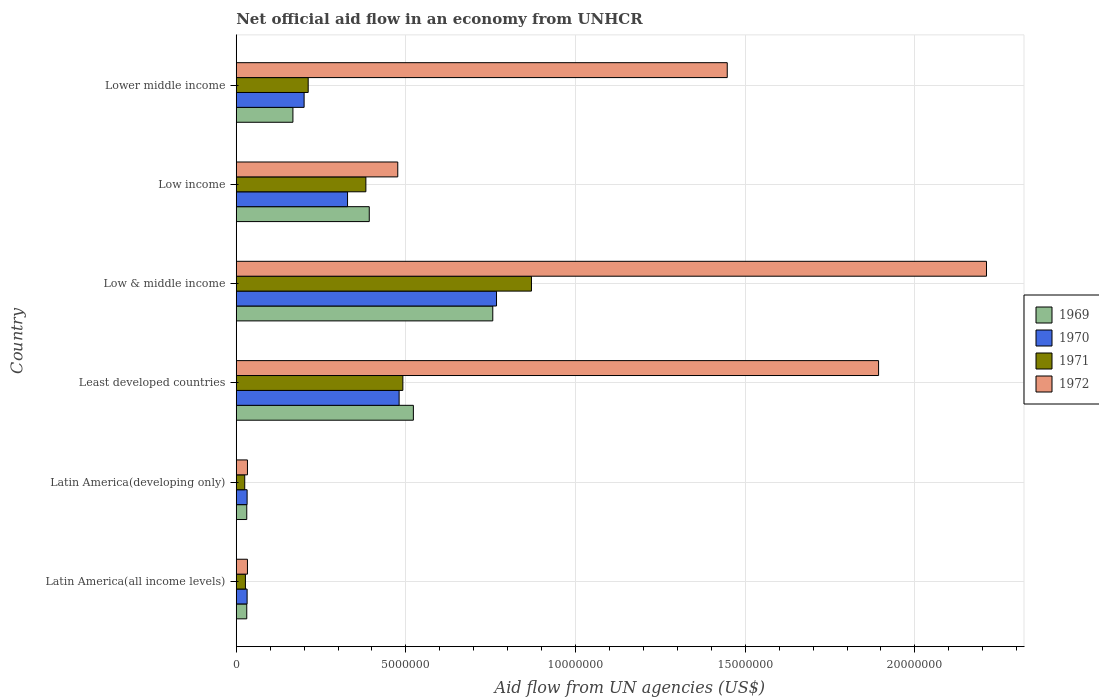How many groups of bars are there?
Offer a terse response. 6. Are the number of bars on each tick of the Y-axis equal?
Keep it short and to the point. Yes. How many bars are there on the 2nd tick from the bottom?
Give a very brief answer. 4. What is the label of the 3rd group of bars from the top?
Your response must be concise. Low & middle income. What is the net official aid flow in 1970 in Latin America(developing only)?
Your answer should be compact. 3.20e+05. Across all countries, what is the maximum net official aid flow in 1969?
Provide a short and direct response. 7.56e+06. Across all countries, what is the minimum net official aid flow in 1969?
Provide a succinct answer. 3.10e+05. In which country was the net official aid flow in 1969 minimum?
Keep it short and to the point. Latin America(all income levels). What is the total net official aid flow in 1970 in the graph?
Keep it short and to the point. 1.84e+07. What is the difference between the net official aid flow in 1972 in Latin America(developing only) and that in Lower middle income?
Keep it short and to the point. -1.41e+07. What is the difference between the net official aid flow in 1971 in Least developed countries and the net official aid flow in 1969 in Low & middle income?
Ensure brevity in your answer.  -2.65e+06. What is the average net official aid flow in 1969 per country?
Ensure brevity in your answer.  3.16e+06. What is the difference between the net official aid flow in 1971 and net official aid flow in 1969 in Low & middle income?
Your answer should be compact. 1.14e+06. What is the ratio of the net official aid flow in 1970 in Latin America(all income levels) to that in Lower middle income?
Your response must be concise. 0.16. What is the difference between the highest and the second highest net official aid flow in 1972?
Provide a succinct answer. 3.18e+06. What is the difference between the highest and the lowest net official aid flow in 1969?
Provide a succinct answer. 7.25e+06. Is it the case that in every country, the sum of the net official aid flow in 1971 and net official aid flow in 1972 is greater than the sum of net official aid flow in 1970 and net official aid flow in 1969?
Ensure brevity in your answer.  No. What does the 2nd bar from the top in Least developed countries represents?
Ensure brevity in your answer.  1971. What does the 3rd bar from the bottom in Low & middle income represents?
Your answer should be very brief. 1971. How many bars are there?
Make the answer very short. 24. How many countries are there in the graph?
Offer a very short reply. 6. What is the difference between two consecutive major ticks on the X-axis?
Offer a very short reply. 5.00e+06. How many legend labels are there?
Offer a very short reply. 4. What is the title of the graph?
Offer a very short reply. Net official aid flow in an economy from UNHCR. What is the label or title of the X-axis?
Give a very brief answer. Aid flow from UN agencies (US$). What is the Aid flow from UN agencies (US$) of 1969 in Latin America(all income levels)?
Offer a terse response. 3.10e+05. What is the Aid flow from UN agencies (US$) in 1972 in Latin America(all income levels)?
Your response must be concise. 3.30e+05. What is the Aid flow from UN agencies (US$) in 1969 in Least developed countries?
Your answer should be very brief. 5.22e+06. What is the Aid flow from UN agencies (US$) of 1970 in Least developed countries?
Make the answer very short. 4.80e+06. What is the Aid flow from UN agencies (US$) of 1971 in Least developed countries?
Ensure brevity in your answer.  4.91e+06. What is the Aid flow from UN agencies (US$) in 1972 in Least developed countries?
Keep it short and to the point. 1.89e+07. What is the Aid flow from UN agencies (US$) of 1969 in Low & middle income?
Provide a short and direct response. 7.56e+06. What is the Aid flow from UN agencies (US$) of 1970 in Low & middle income?
Offer a terse response. 7.67e+06. What is the Aid flow from UN agencies (US$) in 1971 in Low & middle income?
Give a very brief answer. 8.70e+06. What is the Aid flow from UN agencies (US$) of 1972 in Low & middle income?
Make the answer very short. 2.21e+07. What is the Aid flow from UN agencies (US$) in 1969 in Low income?
Your answer should be compact. 3.92e+06. What is the Aid flow from UN agencies (US$) in 1970 in Low income?
Your answer should be very brief. 3.28e+06. What is the Aid flow from UN agencies (US$) of 1971 in Low income?
Offer a terse response. 3.82e+06. What is the Aid flow from UN agencies (US$) in 1972 in Low income?
Give a very brief answer. 4.76e+06. What is the Aid flow from UN agencies (US$) in 1969 in Lower middle income?
Your answer should be compact. 1.67e+06. What is the Aid flow from UN agencies (US$) in 1971 in Lower middle income?
Ensure brevity in your answer.  2.12e+06. What is the Aid flow from UN agencies (US$) of 1972 in Lower middle income?
Ensure brevity in your answer.  1.45e+07. Across all countries, what is the maximum Aid flow from UN agencies (US$) in 1969?
Your answer should be very brief. 7.56e+06. Across all countries, what is the maximum Aid flow from UN agencies (US$) in 1970?
Provide a succinct answer. 7.67e+06. Across all countries, what is the maximum Aid flow from UN agencies (US$) in 1971?
Offer a very short reply. 8.70e+06. Across all countries, what is the maximum Aid flow from UN agencies (US$) of 1972?
Ensure brevity in your answer.  2.21e+07. Across all countries, what is the minimum Aid flow from UN agencies (US$) of 1972?
Ensure brevity in your answer.  3.30e+05. What is the total Aid flow from UN agencies (US$) of 1969 in the graph?
Offer a terse response. 1.90e+07. What is the total Aid flow from UN agencies (US$) in 1970 in the graph?
Make the answer very short. 1.84e+07. What is the total Aid flow from UN agencies (US$) in 1971 in the graph?
Keep it short and to the point. 2.01e+07. What is the total Aid flow from UN agencies (US$) in 1972 in the graph?
Your response must be concise. 6.09e+07. What is the difference between the Aid flow from UN agencies (US$) of 1969 in Latin America(all income levels) and that in Latin America(developing only)?
Provide a short and direct response. 0. What is the difference between the Aid flow from UN agencies (US$) of 1970 in Latin America(all income levels) and that in Latin America(developing only)?
Offer a terse response. 0. What is the difference between the Aid flow from UN agencies (US$) in 1969 in Latin America(all income levels) and that in Least developed countries?
Provide a short and direct response. -4.91e+06. What is the difference between the Aid flow from UN agencies (US$) in 1970 in Latin America(all income levels) and that in Least developed countries?
Offer a terse response. -4.48e+06. What is the difference between the Aid flow from UN agencies (US$) in 1971 in Latin America(all income levels) and that in Least developed countries?
Provide a short and direct response. -4.64e+06. What is the difference between the Aid flow from UN agencies (US$) of 1972 in Latin America(all income levels) and that in Least developed countries?
Make the answer very short. -1.86e+07. What is the difference between the Aid flow from UN agencies (US$) of 1969 in Latin America(all income levels) and that in Low & middle income?
Offer a terse response. -7.25e+06. What is the difference between the Aid flow from UN agencies (US$) of 1970 in Latin America(all income levels) and that in Low & middle income?
Give a very brief answer. -7.35e+06. What is the difference between the Aid flow from UN agencies (US$) of 1971 in Latin America(all income levels) and that in Low & middle income?
Provide a succinct answer. -8.43e+06. What is the difference between the Aid flow from UN agencies (US$) in 1972 in Latin America(all income levels) and that in Low & middle income?
Your response must be concise. -2.18e+07. What is the difference between the Aid flow from UN agencies (US$) of 1969 in Latin America(all income levels) and that in Low income?
Give a very brief answer. -3.61e+06. What is the difference between the Aid flow from UN agencies (US$) in 1970 in Latin America(all income levels) and that in Low income?
Your answer should be compact. -2.96e+06. What is the difference between the Aid flow from UN agencies (US$) in 1971 in Latin America(all income levels) and that in Low income?
Ensure brevity in your answer.  -3.55e+06. What is the difference between the Aid flow from UN agencies (US$) in 1972 in Latin America(all income levels) and that in Low income?
Keep it short and to the point. -4.43e+06. What is the difference between the Aid flow from UN agencies (US$) of 1969 in Latin America(all income levels) and that in Lower middle income?
Your answer should be very brief. -1.36e+06. What is the difference between the Aid flow from UN agencies (US$) of 1970 in Latin America(all income levels) and that in Lower middle income?
Provide a short and direct response. -1.68e+06. What is the difference between the Aid flow from UN agencies (US$) in 1971 in Latin America(all income levels) and that in Lower middle income?
Give a very brief answer. -1.85e+06. What is the difference between the Aid flow from UN agencies (US$) of 1972 in Latin America(all income levels) and that in Lower middle income?
Offer a very short reply. -1.41e+07. What is the difference between the Aid flow from UN agencies (US$) in 1969 in Latin America(developing only) and that in Least developed countries?
Keep it short and to the point. -4.91e+06. What is the difference between the Aid flow from UN agencies (US$) of 1970 in Latin America(developing only) and that in Least developed countries?
Provide a short and direct response. -4.48e+06. What is the difference between the Aid flow from UN agencies (US$) in 1971 in Latin America(developing only) and that in Least developed countries?
Offer a very short reply. -4.66e+06. What is the difference between the Aid flow from UN agencies (US$) in 1972 in Latin America(developing only) and that in Least developed countries?
Give a very brief answer. -1.86e+07. What is the difference between the Aid flow from UN agencies (US$) of 1969 in Latin America(developing only) and that in Low & middle income?
Keep it short and to the point. -7.25e+06. What is the difference between the Aid flow from UN agencies (US$) in 1970 in Latin America(developing only) and that in Low & middle income?
Your response must be concise. -7.35e+06. What is the difference between the Aid flow from UN agencies (US$) of 1971 in Latin America(developing only) and that in Low & middle income?
Keep it short and to the point. -8.45e+06. What is the difference between the Aid flow from UN agencies (US$) of 1972 in Latin America(developing only) and that in Low & middle income?
Provide a succinct answer. -2.18e+07. What is the difference between the Aid flow from UN agencies (US$) in 1969 in Latin America(developing only) and that in Low income?
Your answer should be compact. -3.61e+06. What is the difference between the Aid flow from UN agencies (US$) in 1970 in Latin America(developing only) and that in Low income?
Give a very brief answer. -2.96e+06. What is the difference between the Aid flow from UN agencies (US$) in 1971 in Latin America(developing only) and that in Low income?
Your response must be concise. -3.57e+06. What is the difference between the Aid flow from UN agencies (US$) in 1972 in Latin America(developing only) and that in Low income?
Ensure brevity in your answer.  -4.43e+06. What is the difference between the Aid flow from UN agencies (US$) in 1969 in Latin America(developing only) and that in Lower middle income?
Your answer should be compact. -1.36e+06. What is the difference between the Aid flow from UN agencies (US$) in 1970 in Latin America(developing only) and that in Lower middle income?
Offer a terse response. -1.68e+06. What is the difference between the Aid flow from UN agencies (US$) of 1971 in Latin America(developing only) and that in Lower middle income?
Provide a succinct answer. -1.87e+06. What is the difference between the Aid flow from UN agencies (US$) of 1972 in Latin America(developing only) and that in Lower middle income?
Your answer should be compact. -1.41e+07. What is the difference between the Aid flow from UN agencies (US$) in 1969 in Least developed countries and that in Low & middle income?
Your answer should be compact. -2.34e+06. What is the difference between the Aid flow from UN agencies (US$) of 1970 in Least developed countries and that in Low & middle income?
Your answer should be compact. -2.87e+06. What is the difference between the Aid flow from UN agencies (US$) of 1971 in Least developed countries and that in Low & middle income?
Ensure brevity in your answer.  -3.79e+06. What is the difference between the Aid flow from UN agencies (US$) of 1972 in Least developed countries and that in Low & middle income?
Provide a succinct answer. -3.18e+06. What is the difference between the Aid flow from UN agencies (US$) of 1969 in Least developed countries and that in Low income?
Your answer should be compact. 1.30e+06. What is the difference between the Aid flow from UN agencies (US$) in 1970 in Least developed countries and that in Low income?
Ensure brevity in your answer.  1.52e+06. What is the difference between the Aid flow from UN agencies (US$) in 1971 in Least developed countries and that in Low income?
Make the answer very short. 1.09e+06. What is the difference between the Aid flow from UN agencies (US$) of 1972 in Least developed countries and that in Low income?
Offer a very short reply. 1.42e+07. What is the difference between the Aid flow from UN agencies (US$) of 1969 in Least developed countries and that in Lower middle income?
Offer a terse response. 3.55e+06. What is the difference between the Aid flow from UN agencies (US$) in 1970 in Least developed countries and that in Lower middle income?
Offer a terse response. 2.80e+06. What is the difference between the Aid flow from UN agencies (US$) in 1971 in Least developed countries and that in Lower middle income?
Keep it short and to the point. 2.79e+06. What is the difference between the Aid flow from UN agencies (US$) in 1972 in Least developed countries and that in Lower middle income?
Make the answer very short. 4.46e+06. What is the difference between the Aid flow from UN agencies (US$) in 1969 in Low & middle income and that in Low income?
Provide a succinct answer. 3.64e+06. What is the difference between the Aid flow from UN agencies (US$) in 1970 in Low & middle income and that in Low income?
Your response must be concise. 4.39e+06. What is the difference between the Aid flow from UN agencies (US$) in 1971 in Low & middle income and that in Low income?
Ensure brevity in your answer.  4.88e+06. What is the difference between the Aid flow from UN agencies (US$) of 1972 in Low & middle income and that in Low income?
Your answer should be very brief. 1.74e+07. What is the difference between the Aid flow from UN agencies (US$) in 1969 in Low & middle income and that in Lower middle income?
Your response must be concise. 5.89e+06. What is the difference between the Aid flow from UN agencies (US$) in 1970 in Low & middle income and that in Lower middle income?
Give a very brief answer. 5.67e+06. What is the difference between the Aid flow from UN agencies (US$) of 1971 in Low & middle income and that in Lower middle income?
Give a very brief answer. 6.58e+06. What is the difference between the Aid flow from UN agencies (US$) in 1972 in Low & middle income and that in Lower middle income?
Your answer should be compact. 7.64e+06. What is the difference between the Aid flow from UN agencies (US$) in 1969 in Low income and that in Lower middle income?
Offer a terse response. 2.25e+06. What is the difference between the Aid flow from UN agencies (US$) in 1970 in Low income and that in Lower middle income?
Your response must be concise. 1.28e+06. What is the difference between the Aid flow from UN agencies (US$) in 1971 in Low income and that in Lower middle income?
Keep it short and to the point. 1.70e+06. What is the difference between the Aid flow from UN agencies (US$) in 1972 in Low income and that in Lower middle income?
Make the answer very short. -9.71e+06. What is the difference between the Aid flow from UN agencies (US$) of 1969 in Latin America(all income levels) and the Aid flow from UN agencies (US$) of 1971 in Latin America(developing only)?
Your answer should be very brief. 6.00e+04. What is the difference between the Aid flow from UN agencies (US$) of 1969 in Latin America(all income levels) and the Aid flow from UN agencies (US$) of 1970 in Least developed countries?
Your answer should be compact. -4.49e+06. What is the difference between the Aid flow from UN agencies (US$) of 1969 in Latin America(all income levels) and the Aid flow from UN agencies (US$) of 1971 in Least developed countries?
Offer a terse response. -4.60e+06. What is the difference between the Aid flow from UN agencies (US$) in 1969 in Latin America(all income levels) and the Aid flow from UN agencies (US$) in 1972 in Least developed countries?
Offer a terse response. -1.86e+07. What is the difference between the Aid flow from UN agencies (US$) of 1970 in Latin America(all income levels) and the Aid flow from UN agencies (US$) of 1971 in Least developed countries?
Give a very brief answer. -4.59e+06. What is the difference between the Aid flow from UN agencies (US$) in 1970 in Latin America(all income levels) and the Aid flow from UN agencies (US$) in 1972 in Least developed countries?
Your answer should be very brief. -1.86e+07. What is the difference between the Aid flow from UN agencies (US$) in 1971 in Latin America(all income levels) and the Aid flow from UN agencies (US$) in 1972 in Least developed countries?
Keep it short and to the point. -1.87e+07. What is the difference between the Aid flow from UN agencies (US$) of 1969 in Latin America(all income levels) and the Aid flow from UN agencies (US$) of 1970 in Low & middle income?
Ensure brevity in your answer.  -7.36e+06. What is the difference between the Aid flow from UN agencies (US$) in 1969 in Latin America(all income levels) and the Aid flow from UN agencies (US$) in 1971 in Low & middle income?
Your response must be concise. -8.39e+06. What is the difference between the Aid flow from UN agencies (US$) of 1969 in Latin America(all income levels) and the Aid flow from UN agencies (US$) of 1972 in Low & middle income?
Provide a short and direct response. -2.18e+07. What is the difference between the Aid flow from UN agencies (US$) of 1970 in Latin America(all income levels) and the Aid flow from UN agencies (US$) of 1971 in Low & middle income?
Ensure brevity in your answer.  -8.38e+06. What is the difference between the Aid flow from UN agencies (US$) in 1970 in Latin America(all income levels) and the Aid flow from UN agencies (US$) in 1972 in Low & middle income?
Offer a very short reply. -2.18e+07. What is the difference between the Aid flow from UN agencies (US$) in 1971 in Latin America(all income levels) and the Aid flow from UN agencies (US$) in 1972 in Low & middle income?
Provide a succinct answer. -2.18e+07. What is the difference between the Aid flow from UN agencies (US$) of 1969 in Latin America(all income levels) and the Aid flow from UN agencies (US$) of 1970 in Low income?
Keep it short and to the point. -2.97e+06. What is the difference between the Aid flow from UN agencies (US$) of 1969 in Latin America(all income levels) and the Aid flow from UN agencies (US$) of 1971 in Low income?
Offer a very short reply. -3.51e+06. What is the difference between the Aid flow from UN agencies (US$) of 1969 in Latin America(all income levels) and the Aid flow from UN agencies (US$) of 1972 in Low income?
Your response must be concise. -4.45e+06. What is the difference between the Aid flow from UN agencies (US$) in 1970 in Latin America(all income levels) and the Aid flow from UN agencies (US$) in 1971 in Low income?
Your response must be concise. -3.50e+06. What is the difference between the Aid flow from UN agencies (US$) in 1970 in Latin America(all income levels) and the Aid flow from UN agencies (US$) in 1972 in Low income?
Offer a terse response. -4.44e+06. What is the difference between the Aid flow from UN agencies (US$) of 1971 in Latin America(all income levels) and the Aid flow from UN agencies (US$) of 1972 in Low income?
Make the answer very short. -4.49e+06. What is the difference between the Aid flow from UN agencies (US$) in 1969 in Latin America(all income levels) and the Aid flow from UN agencies (US$) in 1970 in Lower middle income?
Provide a succinct answer. -1.69e+06. What is the difference between the Aid flow from UN agencies (US$) in 1969 in Latin America(all income levels) and the Aid flow from UN agencies (US$) in 1971 in Lower middle income?
Your answer should be compact. -1.81e+06. What is the difference between the Aid flow from UN agencies (US$) in 1969 in Latin America(all income levels) and the Aid flow from UN agencies (US$) in 1972 in Lower middle income?
Give a very brief answer. -1.42e+07. What is the difference between the Aid flow from UN agencies (US$) of 1970 in Latin America(all income levels) and the Aid flow from UN agencies (US$) of 1971 in Lower middle income?
Provide a short and direct response. -1.80e+06. What is the difference between the Aid flow from UN agencies (US$) in 1970 in Latin America(all income levels) and the Aid flow from UN agencies (US$) in 1972 in Lower middle income?
Offer a terse response. -1.42e+07. What is the difference between the Aid flow from UN agencies (US$) of 1971 in Latin America(all income levels) and the Aid flow from UN agencies (US$) of 1972 in Lower middle income?
Your answer should be compact. -1.42e+07. What is the difference between the Aid flow from UN agencies (US$) in 1969 in Latin America(developing only) and the Aid flow from UN agencies (US$) in 1970 in Least developed countries?
Ensure brevity in your answer.  -4.49e+06. What is the difference between the Aid flow from UN agencies (US$) in 1969 in Latin America(developing only) and the Aid flow from UN agencies (US$) in 1971 in Least developed countries?
Give a very brief answer. -4.60e+06. What is the difference between the Aid flow from UN agencies (US$) of 1969 in Latin America(developing only) and the Aid flow from UN agencies (US$) of 1972 in Least developed countries?
Your answer should be very brief. -1.86e+07. What is the difference between the Aid flow from UN agencies (US$) of 1970 in Latin America(developing only) and the Aid flow from UN agencies (US$) of 1971 in Least developed countries?
Keep it short and to the point. -4.59e+06. What is the difference between the Aid flow from UN agencies (US$) in 1970 in Latin America(developing only) and the Aid flow from UN agencies (US$) in 1972 in Least developed countries?
Provide a succinct answer. -1.86e+07. What is the difference between the Aid flow from UN agencies (US$) in 1971 in Latin America(developing only) and the Aid flow from UN agencies (US$) in 1972 in Least developed countries?
Provide a succinct answer. -1.87e+07. What is the difference between the Aid flow from UN agencies (US$) of 1969 in Latin America(developing only) and the Aid flow from UN agencies (US$) of 1970 in Low & middle income?
Provide a short and direct response. -7.36e+06. What is the difference between the Aid flow from UN agencies (US$) of 1969 in Latin America(developing only) and the Aid flow from UN agencies (US$) of 1971 in Low & middle income?
Your response must be concise. -8.39e+06. What is the difference between the Aid flow from UN agencies (US$) of 1969 in Latin America(developing only) and the Aid flow from UN agencies (US$) of 1972 in Low & middle income?
Your answer should be compact. -2.18e+07. What is the difference between the Aid flow from UN agencies (US$) of 1970 in Latin America(developing only) and the Aid flow from UN agencies (US$) of 1971 in Low & middle income?
Make the answer very short. -8.38e+06. What is the difference between the Aid flow from UN agencies (US$) in 1970 in Latin America(developing only) and the Aid flow from UN agencies (US$) in 1972 in Low & middle income?
Provide a succinct answer. -2.18e+07. What is the difference between the Aid flow from UN agencies (US$) in 1971 in Latin America(developing only) and the Aid flow from UN agencies (US$) in 1972 in Low & middle income?
Offer a very short reply. -2.19e+07. What is the difference between the Aid flow from UN agencies (US$) of 1969 in Latin America(developing only) and the Aid flow from UN agencies (US$) of 1970 in Low income?
Keep it short and to the point. -2.97e+06. What is the difference between the Aid flow from UN agencies (US$) of 1969 in Latin America(developing only) and the Aid flow from UN agencies (US$) of 1971 in Low income?
Ensure brevity in your answer.  -3.51e+06. What is the difference between the Aid flow from UN agencies (US$) in 1969 in Latin America(developing only) and the Aid flow from UN agencies (US$) in 1972 in Low income?
Ensure brevity in your answer.  -4.45e+06. What is the difference between the Aid flow from UN agencies (US$) of 1970 in Latin America(developing only) and the Aid flow from UN agencies (US$) of 1971 in Low income?
Keep it short and to the point. -3.50e+06. What is the difference between the Aid flow from UN agencies (US$) of 1970 in Latin America(developing only) and the Aid flow from UN agencies (US$) of 1972 in Low income?
Make the answer very short. -4.44e+06. What is the difference between the Aid flow from UN agencies (US$) in 1971 in Latin America(developing only) and the Aid flow from UN agencies (US$) in 1972 in Low income?
Keep it short and to the point. -4.51e+06. What is the difference between the Aid flow from UN agencies (US$) in 1969 in Latin America(developing only) and the Aid flow from UN agencies (US$) in 1970 in Lower middle income?
Provide a short and direct response. -1.69e+06. What is the difference between the Aid flow from UN agencies (US$) in 1969 in Latin America(developing only) and the Aid flow from UN agencies (US$) in 1971 in Lower middle income?
Give a very brief answer. -1.81e+06. What is the difference between the Aid flow from UN agencies (US$) in 1969 in Latin America(developing only) and the Aid flow from UN agencies (US$) in 1972 in Lower middle income?
Provide a short and direct response. -1.42e+07. What is the difference between the Aid flow from UN agencies (US$) in 1970 in Latin America(developing only) and the Aid flow from UN agencies (US$) in 1971 in Lower middle income?
Ensure brevity in your answer.  -1.80e+06. What is the difference between the Aid flow from UN agencies (US$) in 1970 in Latin America(developing only) and the Aid flow from UN agencies (US$) in 1972 in Lower middle income?
Provide a succinct answer. -1.42e+07. What is the difference between the Aid flow from UN agencies (US$) in 1971 in Latin America(developing only) and the Aid flow from UN agencies (US$) in 1972 in Lower middle income?
Ensure brevity in your answer.  -1.42e+07. What is the difference between the Aid flow from UN agencies (US$) of 1969 in Least developed countries and the Aid flow from UN agencies (US$) of 1970 in Low & middle income?
Your answer should be compact. -2.45e+06. What is the difference between the Aid flow from UN agencies (US$) in 1969 in Least developed countries and the Aid flow from UN agencies (US$) in 1971 in Low & middle income?
Provide a short and direct response. -3.48e+06. What is the difference between the Aid flow from UN agencies (US$) in 1969 in Least developed countries and the Aid flow from UN agencies (US$) in 1972 in Low & middle income?
Your answer should be compact. -1.69e+07. What is the difference between the Aid flow from UN agencies (US$) in 1970 in Least developed countries and the Aid flow from UN agencies (US$) in 1971 in Low & middle income?
Offer a terse response. -3.90e+06. What is the difference between the Aid flow from UN agencies (US$) in 1970 in Least developed countries and the Aid flow from UN agencies (US$) in 1972 in Low & middle income?
Provide a succinct answer. -1.73e+07. What is the difference between the Aid flow from UN agencies (US$) of 1971 in Least developed countries and the Aid flow from UN agencies (US$) of 1972 in Low & middle income?
Give a very brief answer. -1.72e+07. What is the difference between the Aid flow from UN agencies (US$) in 1969 in Least developed countries and the Aid flow from UN agencies (US$) in 1970 in Low income?
Your answer should be very brief. 1.94e+06. What is the difference between the Aid flow from UN agencies (US$) of 1969 in Least developed countries and the Aid flow from UN agencies (US$) of 1971 in Low income?
Your answer should be compact. 1.40e+06. What is the difference between the Aid flow from UN agencies (US$) of 1970 in Least developed countries and the Aid flow from UN agencies (US$) of 1971 in Low income?
Your answer should be compact. 9.80e+05. What is the difference between the Aid flow from UN agencies (US$) in 1970 in Least developed countries and the Aid flow from UN agencies (US$) in 1972 in Low income?
Keep it short and to the point. 4.00e+04. What is the difference between the Aid flow from UN agencies (US$) of 1969 in Least developed countries and the Aid flow from UN agencies (US$) of 1970 in Lower middle income?
Offer a terse response. 3.22e+06. What is the difference between the Aid flow from UN agencies (US$) in 1969 in Least developed countries and the Aid flow from UN agencies (US$) in 1971 in Lower middle income?
Provide a short and direct response. 3.10e+06. What is the difference between the Aid flow from UN agencies (US$) of 1969 in Least developed countries and the Aid flow from UN agencies (US$) of 1972 in Lower middle income?
Keep it short and to the point. -9.25e+06. What is the difference between the Aid flow from UN agencies (US$) of 1970 in Least developed countries and the Aid flow from UN agencies (US$) of 1971 in Lower middle income?
Ensure brevity in your answer.  2.68e+06. What is the difference between the Aid flow from UN agencies (US$) in 1970 in Least developed countries and the Aid flow from UN agencies (US$) in 1972 in Lower middle income?
Offer a very short reply. -9.67e+06. What is the difference between the Aid flow from UN agencies (US$) in 1971 in Least developed countries and the Aid flow from UN agencies (US$) in 1972 in Lower middle income?
Make the answer very short. -9.56e+06. What is the difference between the Aid flow from UN agencies (US$) in 1969 in Low & middle income and the Aid flow from UN agencies (US$) in 1970 in Low income?
Keep it short and to the point. 4.28e+06. What is the difference between the Aid flow from UN agencies (US$) of 1969 in Low & middle income and the Aid flow from UN agencies (US$) of 1971 in Low income?
Provide a short and direct response. 3.74e+06. What is the difference between the Aid flow from UN agencies (US$) in 1969 in Low & middle income and the Aid flow from UN agencies (US$) in 1972 in Low income?
Your answer should be compact. 2.80e+06. What is the difference between the Aid flow from UN agencies (US$) in 1970 in Low & middle income and the Aid flow from UN agencies (US$) in 1971 in Low income?
Make the answer very short. 3.85e+06. What is the difference between the Aid flow from UN agencies (US$) in 1970 in Low & middle income and the Aid flow from UN agencies (US$) in 1972 in Low income?
Keep it short and to the point. 2.91e+06. What is the difference between the Aid flow from UN agencies (US$) of 1971 in Low & middle income and the Aid flow from UN agencies (US$) of 1972 in Low income?
Provide a succinct answer. 3.94e+06. What is the difference between the Aid flow from UN agencies (US$) of 1969 in Low & middle income and the Aid flow from UN agencies (US$) of 1970 in Lower middle income?
Ensure brevity in your answer.  5.56e+06. What is the difference between the Aid flow from UN agencies (US$) of 1969 in Low & middle income and the Aid flow from UN agencies (US$) of 1971 in Lower middle income?
Make the answer very short. 5.44e+06. What is the difference between the Aid flow from UN agencies (US$) in 1969 in Low & middle income and the Aid flow from UN agencies (US$) in 1972 in Lower middle income?
Offer a very short reply. -6.91e+06. What is the difference between the Aid flow from UN agencies (US$) of 1970 in Low & middle income and the Aid flow from UN agencies (US$) of 1971 in Lower middle income?
Provide a succinct answer. 5.55e+06. What is the difference between the Aid flow from UN agencies (US$) in 1970 in Low & middle income and the Aid flow from UN agencies (US$) in 1972 in Lower middle income?
Your response must be concise. -6.80e+06. What is the difference between the Aid flow from UN agencies (US$) of 1971 in Low & middle income and the Aid flow from UN agencies (US$) of 1972 in Lower middle income?
Your answer should be compact. -5.77e+06. What is the difference between the Aid flow from UN agencies (US$) of 1969 in Low income and the Aid flow from UN agencies (US$) of 1970 in Lower middle income?
Ensure brevity in your answer.  1.92e+06. What is the difference between the Aid flow from UN agencies (US$) of 1969 in Low income and the Aid flow from UN agencies (US$) of 1971 in Lower middle income?
Your response must be concise. 1.80e+06. What is the difference between the Aid flow from UN agencies (US$) of 1969 in Low income and the Aid flow from UN agencies (US$) of 1972 in Lower middle income?
Your answer should be compact. -1.06e+07. What is the difference between the Aid flow from UN agencies (US$) in 1970 in Low income and the Aid flow from UN agencies (US$) in 1971 in Lower middle income?
Provide a short and direct response. 1.16e+06. What is the difference between the Aid flow from UN agencies (US$) in 1970 in Low income and the Aid flow from UN agencies (US$) in 1972 in Lower middle income?
Give a very brief answer. -1.12e+07. What is the difference between the Aid flow from UN agencies (US$) of 1971 in Low income and the Aid flow from UN agencies (US$) of 1972 in Lower middle income?
Your response must be concise. -1.06e+07. What is the average Aid flow from UN agencies (US$) of 1969 per country?
Provide a short and direct response. 3.16e+06. What is the average Aid flow from UN agencies (US$) in 1970 per country?
Your answer should be very brief. 3.06e+06. What is the average Aid flow from UN agencies (US$) in 1971 per country?
Offer a terse response. 3.34e+06. What is the average Aid flow from UN agencies (US$) of 1972 per country?
Provide a short and direct response. 1.02e+07. What is the difference between the Aid flow from UN agencies (US$) of 1969 and Aid flow from UN agencies (US$) of 1971 in Latin America(all income levels)?
Your answer should be very brief. 4.00e+04. What is the difference between the Aid flow from UN agencies (US$) of 1969 and Aid flow from UN agencies (US$) of 1972 in Latin America(all income levels)?
Keep it short and to the point. -2.00e+04. What is the difference between the Aid flow from UN agencies (US$) in 1970 and Aid flow from UN agencies (US$) in 1971 in Latin America(all income levels)?
Make the answer very short. 5.00e+04. What is the difference between the Aid flow from UN agencies (US$) of 1970 and Aid flow from UN agencies (US$) of 1972 in Latin America(all income levels)?
Make the answer very short. -10000. What is the difference between the Aid flow from UN agencies (US$) in 1971 and Aid flow from UN agencies (US$) in 1972 in Latin America(all income levels)?
Ensure brevity in your answer.  -6.00e+04. What is the difference between the Aid flow from UN agencies (US$) of 1969 and Aid flow from UN agencies (US$) of 1970 in Latin America(developing only)?
Give a very brief answer. -10000. What is the difference between the Aid flow from UN agencies (US$) in 1969 and Aid flow from UN agencies (US$) in 1971 in Latin America(developing only)?
Offer a terse response. 6.00e+04. What is the difference between the Aid flow from UN agencies (US$) of 1970 and Aid flow from UN agencies (US$) of 1971 in Latin America(developing only)?
Your answer should be compact. 7.00e+04. What is the difference between the Aid flow from UN agencies (US$) of 1970 and Aid flow from UN agencies (US$) of 1972 in Latin America(developing only)?
Your response must be concise. -10000. What is the difference between the Aid flow from UN agencies (US$) of 1969 and Aid flow from UN agencies (US$) of 1972 in Least developed countries?
Provide a short and direct response. -1.37e+07. What is the difference between the Aid flow from UN agencies (US$) in 1970 and Aid flow from UN agencies (US$) in 1972 in Least developed countries?
Your answer should be very brief. -1.41e+07. What is the difference between the Aid flow from UN agencies (US$) in 1971 and Aid flow from UN agencies (US$) in 1972 in Least developed countries?
Provide a succinct answer. -1.40e+07. What is the difference between the Aid flow from UN agencies (US$) in 1969 and Aid flow from UN agencies (US$) in 1970 in Low & middle income?
Your response must be concise. -1.10e+05. What is the difference between the Aid flow from UN agencies (US$) of 1969 and Aid flow from UN agencies (US$) of 1971 in Low & middle income?
Give a very brief answer. -1.14e+06. What is the difference between the Aid flow from UN agencies (US$) in 1969 and Aid flow from UN agencies (US$) in 1972 in Low & middle income?
Offer a very short reply. -1.46e+07. What is the difference between the Aid flow from UN agencies (US$) in 1970 and Aid flow from UN agencies (US$) in 1971 in Low & middle income?
Give a very brief answer. -1.03e+06. What is the difference between the Aid flow from UN agencies (US$) in 1970 and Aid flow from UN agencies (US$) in 1972 in Low & middle income?
Keep it short and to the point. -1.44e+07. What is the difference between the Aid flow from UN agencies (US$) of 1971 and Aid flow from UN agencies (US$) of 1972 in Low & middle income?
Give a very brief answer. -1.34e+07. What is the difference between the Aid flow from UN agencies (US$) of 1969 and Aid flow from UN agencies (US$) of 1970 in Low income?
Make the answer very short. 6.40e+05. What is the difference between the Aid flow from UN agencies (US$) of 1969 and Aid flow from UN agencies (US$) of 1972 in Low income?
Keep it short and to the point. -8.40e+05. What is the difference between the Aid flow from UN agencies (US$) of 1970 and Aid flow from UN agencies (US$) of 1971 in Low income?
Your response must be concise. -5.40e+05. What is the difference between the Aid flow from UN agencies (US$) in 1970 and Aid flow from UN agencies (US$) in 1972 in Low income?
Offer a terse response. -1.48e+06. What is the difference between the Aid flow from UN agencies (US$) in 1971 and Aid flow from UN agencies (US$) in 1972 in Low income?
Keep it short and to the point. -9.40e+05. What is the difference between the Aid flow from UN agencies (US$) in 1969 and Aid flow from UN agencies (US$) in 1970 in Lower middle income?
Your answer should be compact. -3.30e+05. What is the difference between the Aid flow from UN agencies (US$) in 1969 and Aid flow from UN agencies (US$) in 1971 in Lower middle income?
Offer a terse response. -4.50e+05. What is the difference between the Aid flow from UN agencies (US$) of 1969 and Aid flow from UN agencies (US$) of 1972 in Lower middle income?
Keep it short and to the point. -1.28e+07. What is the difference between the Aid flow from UN agencies (US$) in 1970 and Aid flow from UN agencies (US$) in 1972 in Lower middle income?
Offer a terse response. -1.25e+07. What is the difference between the Aid flow from UN agencies (US$) in 1971 and Aid flow from UN agencies (US$) in 1972 in Lower middle income?
Ensure brevity in your answer.  -1.24e+07. What is the ratio of the Aid flow from UN agencies (US$) in 1970 in Latin America(all income levels) to that in Latin America(developing only)?
Offer a terse response. 1. What is the ratio of the Aid flow from UN agencies (US$) in 1971 in Latin America(all income levels) to that in Latin America(developing only)?
Your answer should be compact. 1.08. What is the ratio of the Aid flow from UN agencies (US$) in 1969 in Latin America(all income levels) to that in Least developed countries?
Your answer should be very brief. 0.06. What is the ratio of the Aid flow from UN agencies (US$) of 1970 in Latin America(all income levels) to that in Least developed countries?
Your answer should be compact. 0.07. What is the ratio of the Aid flow from UN agencies (US$) in 1971 in Latin America(all income levels) to that in Least developed countries?
Offer a very short reply. 0.06. What is the ratio of the Aid flow from UN agencies (US$) of 1972 in Latin America(all income levels) to that in Least developed countries?
Offer a terse response. 0.02. What is the ratio of the Aid flow from UN agencies (US$) of 1969 in Latin America(all income levels) to that in Low & middle income?
Provide a short and direct response. 0.04. What is the ratio of the Aid flow from UN agencies (US$) in 1970 in Latin America(all income levels) to that in Low & middle income?
Keep it short and to the point. 0.04. What is the ratio of the Aid flow from UN agencies (US$) in 1971 in Latin America(all income levels) to that in Low & middle income?
Offer a terse response. 0.03. What is the ratio of the Aid flow from UN agencies (US$) of 1972 in Latin America(all income levels) to that in Low & middle income?
Make the answer very short. 0.01. What is the ratio of the Aid flow from UN agencies (US$) of 1969 in Latin America(all income levels) to that in Low income?
Your answer should be compact. 0.08. What is the ratio of the Aid flow from UN agencies (US$) of 1970 in Latin America(all income levels) to that in Low income?
Ensure brevity in your answer.  0.1. What is the ratio of the Aid flow from UN agencies (US$) in 1971 in Latin America(all income levels) to that in Low income?
Your response must be concise. 0.07. What is the ratio of the Aid flow from UN agencies (US$) of 1972 in Latin America(all income levels) to that in Low income?
Your answer should be very brief. 0.07. What is the ratio of the Aid flow from UN agencies (US$) in 1969 in Latin America(all income levels) to that in Lower middle income?
Offer a terse response. 0.19. What is the ratio of the Aid flow from UN agencies (US$) of 1970 in Latin America(all income levels) to that in Lower middle income?
Offer a terse response. 0.16. What is the ratio of the Aid flow from UN agencies (US$) of 1971 in Latin America(all income levels) to that in Lower middle income?
Give a very brief answer. 0.13. What is the ratio of the Aid flow from UN agencies (US$) of 1972 in Latin America(all income levels) to that in Lower middle income?
Offer a terse response. 0.02. What is the ratio of the Aid flow from UN agencies (US$) of 1969 in Latin America(developing only) to that in Least developed countries?
Provide a succinct answer. 0.06. What is the ratio of the Aid flow from UN agencies (US$) of 1970 in Latin America(developing only) to that in Least developed countries?
Your answer should be compact. 0.07. What is the ratio of the Aid flow from UN agencies (US$) of 1971 in Latin America(developing only) to that in Least developed countries?
Give a very brief answer. 0.05. What is the ratio of the Aid flow from UN agencies (US$) in 1972 in Latin America(developing only) to that in Least developed countries?
Provide a short and direct response. 0.02. What is the ratio of the Aid flow from UN agencies (US$) in 1969 in Latin America(developing only) to that in Low & middle income?
Provide a succinct answer. 0.04. What is the ratio of the Aid flow from UN agencies (US$) of 1970 in Latin America(developing only) to that in Low & middle income?
Provide a short and direct response. 0.04. What is the ratio of the Aid flow from UN agencies (US$) of 1971 in Latin America(developing only) to that in Low & middle income?
Ensure brevity in your answer.  0.03. What is the ratio of the Aid flow from UN agencies (US$) of 1972 in Latin America(developing only) to that in Low & middle income?
Your response must be concise. 0.01. What is the ratio of the Aid flow from UN agencies (US$) of 1969 in Latin America(developing only) to that in Low income?
Keep it short and to the point. 0.08. What is the ratio of the Aid flow from UN agencies (US$) of 1970 in Latin America(developing only) to that in Low income?
Your answer should be very brief. 0.1. What is the ratio of the Aid flow from UN agencies (US$) in 1971 in Latin America(developing only) to that in Low income?
Provide a short and direct response. 0.07. What is the ratio of the Aid flow from UN agencies (US$) in 1972 in Latin America(developing only) to that in Low income?
Your answer should be compact. 0.07. What is the ratio of the Aid flow from UN agencies (US$) in 1969 in Latin America(developing only) to that in Lower middle income?
Provide a succinct answer. 0.19. What is the ratio of the Aid flow from UN agencies (US$) in 1970 in Latin America(developing only) to that in Lower middle income?
Make the answer very short. 0.16. What is the ratio of the Aid flow from UN agencies (US$) of 1971 in Latin America(developing only) to that in Lower middle income?
Provide a succinct answer. 0.12. What is the ratio of the Aid flow from UN agencies (US$) in 1972 in Latin America(developing only) to that in Lower middle income?
Your answer should be very brief. 0.02. What is the ratio of the Aid flow from UN agencies (US$) in 1969 in Least developed countries to that in Low & middle income?
Your answer should be compact. 0.69. What is the ratio of the Aid flow from UN agencies (US$) in 1970 in Least developed countries to that in Low & middle income?
Ensure brevity in your answer.  0.63. What is the ratio of the Aid flow from UN agencies (US$) of 1971 in Least developed countries to that in Low & middle income?
Ensure brevity in your answer.  0.56. What is the ratio of the Aid flow from UN agencies (US$) of 1972 in Least developed countries to that in Low & middle income?
Your answer should be compact. 0.86. What is the ratio of the Aid flow from UN agencies (US$) in 1969 in Least developed countries to that in Low income?
Your response must be concise. 1.33. What is the ratio of the Aid flow from UN agencies (US$) of 1970 in Least developed countries to that in Low income?
Offer a terse response. 1.46. What is the ratio of the Aid flow from UN agencies (US$) of 1971 in Least developed countries to that in Low income?
Make the answer very short. 1.29. What is the ratio of the Aid flow from UN agencies (US$) in 1972 in Least developed countries to that in Low income?
Your response must be concise. 3.98. What is the ratio of the Aid flow from UN agencies (US$) of 1969 in Least developed countries to that in Lower middle income?
Ensure brevity in your answer.  3.13. What is the ratio of the Aid flow from UN agencies (US$) of 1970 in Least developed countries to that in Lower middle income?
Make the answer very short. 2.4. What is the ratio of the Aid flow from UN agencies (US$) in 1971 in Least developed countries to that in Lower middle income?
Offer a terse response. 2.32. What is the ratio of the Aid flow from UN agencies (US$) in 1972 in Least developed countries to that in Lower middle income?
Offer a very short reply. 1.31. What is the ratio of the Aid flow from UN agencies (US$) of 1969 in Low & middle income to that in Low income?
Keep it short and to the point. 1.93. What is the ratio of the Aid flow from UN agencies (US$) in 1970 in Low & middle income to that in Low income?
Your answer should be very brief. 2.34. What is the ratio of the Aid flow from UN agencies (US$) of 1971 in Low & middle income to that in Low income?
Offer a terse response. 2.28. What is the ratio of the Aid flow from UN agencies (US$) in 1972 in Low & middle income to that in Low income?
Your answer should be compact. 4.64. What is the ratio of the Aid flow from UN agencies (US$) in 1969 in Low & middle income to that in Lower middle income?
Provide a succinct answer. 4.53. What is the ratio of the Aid flow from UN agencies (US$) of 1970 in Low & middle income to that in Lower middle income?
Your response must be concise. 3.83. What is the ratio of the Aid flow from UN agencies (US$) in 1971 in Low & middle income to that in Lower middle income?
Give a very brief answer. 4.1. What is the ratio of the Aid flow from UN agencies (US$) of 1972 in Low & middle income to that in Lower middle income?
Make the answer very short. 1.53. What is the ratio of the Aid flow from UN agencies (US$) of 1969 in Low income to that in Lower middle income?
Provide a short and direct response. 2.35. What is the ratio of the Aid flow from UN agencies (US$) in 1970 in Low income to that in Lower middle income?
Offer a very short reply. 1.64. What is the ratio of the Aid flow from UN agencies (US$) of 1971 in Low income to that in Lower middle income?
Ensure brevity in your answer.  1.8. What is the ratio of the Aid flow from UN agencies (US$) in 1972 in Low income to that in Lower middle income?
Provide a short and direct response. 0.33. What is the difference between the highest and the second highest Aid flow from UN agencies (US$) in 1969?
Provide a short and direct response. 2.34e+06. What is the difference between the highest and the second highest Aid flow from UN agencies (US$) in 1970?
Provide a short and direct response. 2.87e+06. What is the difference between the highest and the second highest Aid flow from UN agencies (US$) in 1971?
Ensure brevity in your answer.  3.79e+06. What is the difference between the highest and the second highest Aid flow from UN agencies (US$) of 1972?
Offer a very short reply. 3.18e+06. What is the difference between the highest and the lowest Aid flow from UN agencies (US$) in 1969?
Your answer should be very brief. 7.25e+06. What is the difference between the highest and the lowest Aid flow from UN agencies (US$) in 1970?
Offer a very short reply. 7.35e+06. What is the difference between the highest and the lowest Aid flow from UN agencies (US$) of 1971?
Make the answer very short. 8.45e+06. What is the difference between the highest and the lowest Aid flow from UN agencies (US$) of 1972?
Provide a short and direct response. 2.18e+07. 